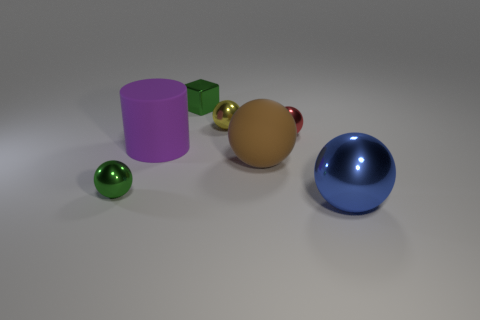Can you describe the objects in the foreground and their colors? Certainly, in the foreground there are two prominent objects: a healthy-looking peach-colored sphere with a reflective surface, and a voluminous blue hemisphere. The hemisphere sits to the right, casting a subtle shadow on the surface beneath it.  What could these objects be used for in a practical sense? The objects seem to be simplistic representations of geometric shapes, typically used for educational purposes to teach about dimensions and spatial understanding. They can also be part of a 3D modeling software's default asset library, used by designers to test lighting and texturing effects. 